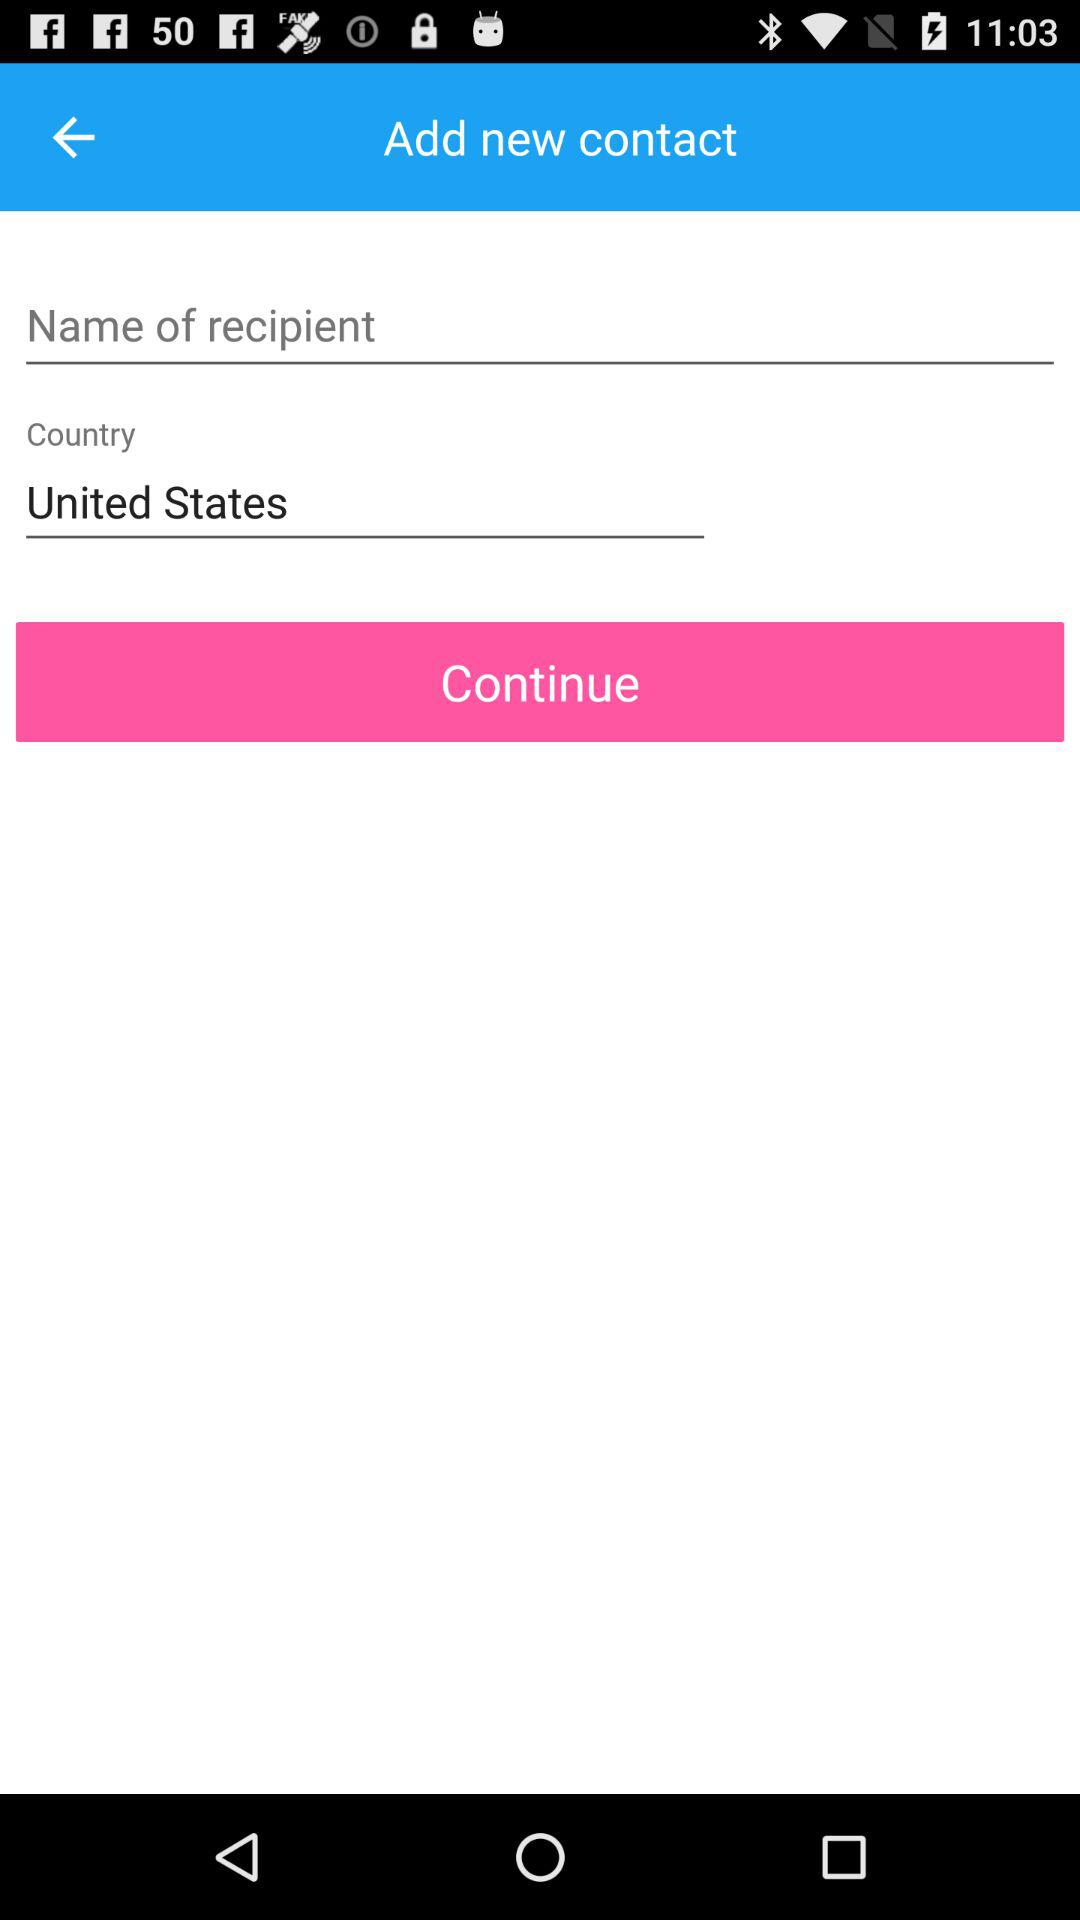What country has been selected? The selected country is the United States. 